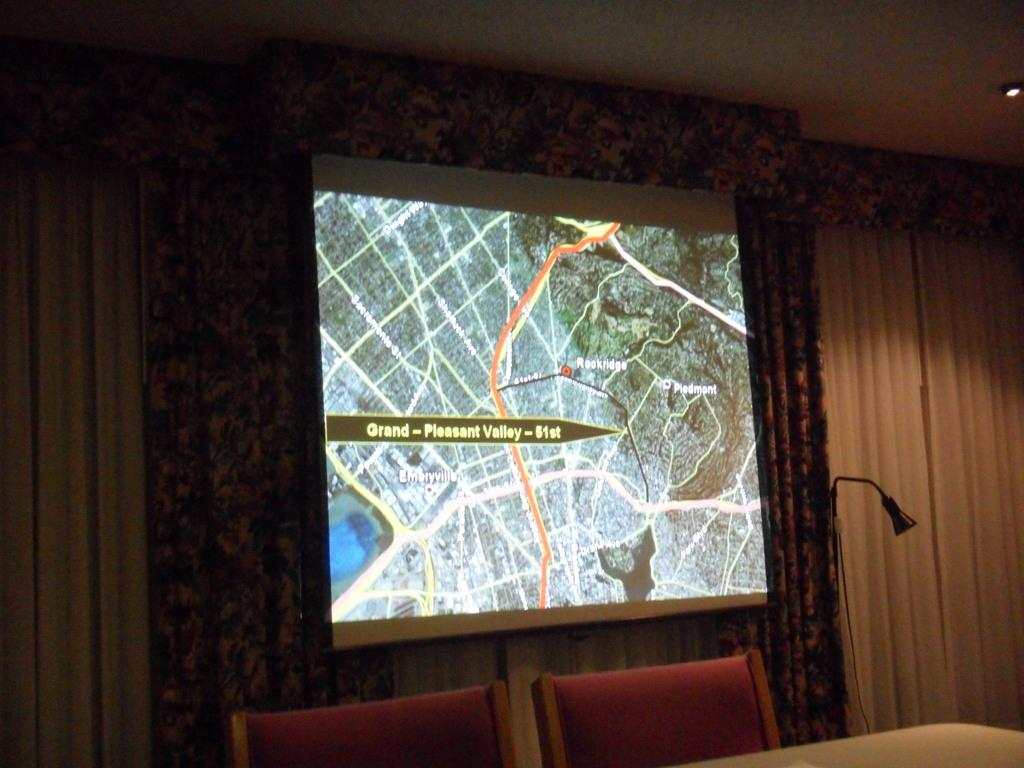What is the main object in the image? There is a display screen in the image. What type of decoration is present on the walls in the image? There are curtains on the walls in the image. What type of furniture is present in the image? There are chairs in the image. What type of lighting is present in the image? There is a table lamp in the image. What type of surface is present in the image for placing objects? There is a table in the image. What type of badge is visible on the display screen in the image? There is no badge visible on the display screen in the image. 